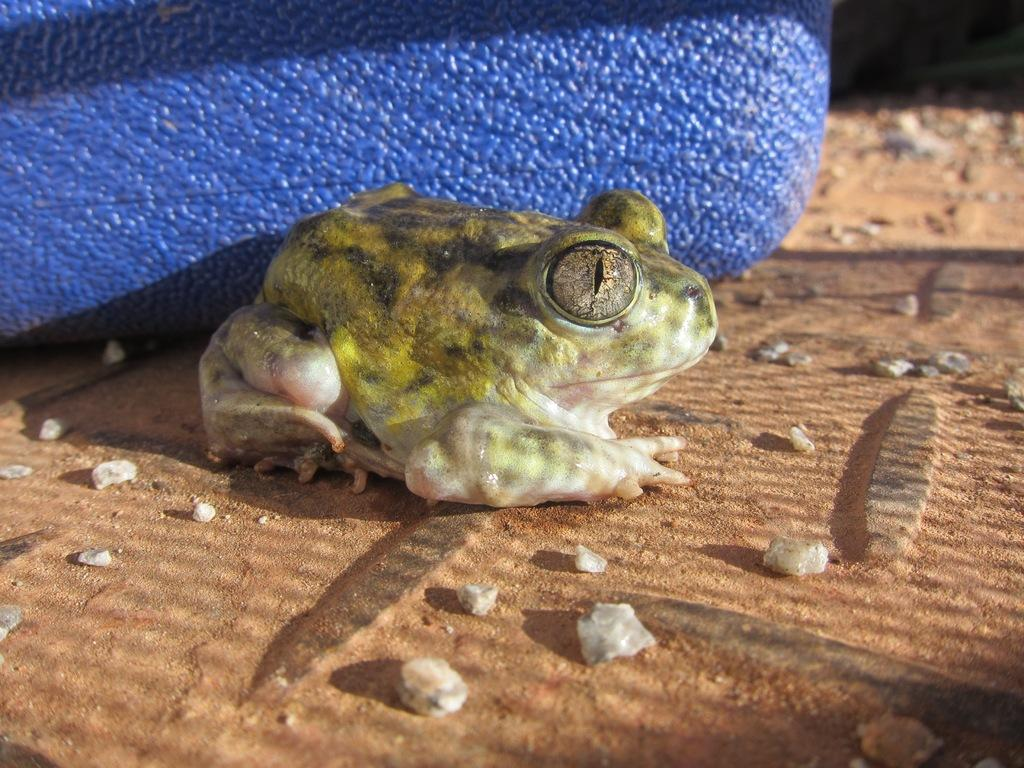What type of animal is in the image? There is a green frog in the image. What is the frog sitting on? The frog is sitting on a brown flooring tile. Can you describe the flooring tile? The flooring tile has white stones. What can be seen in the background of the image? There is a blue box in the background of the image. How many eyes does the question have in the image? There is no question present in the image, and therefore no eyes can be attributed to it. 